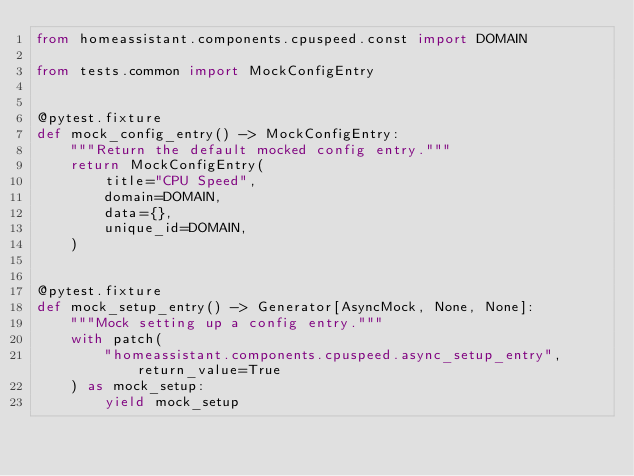Convert code to text. <code><loc_0><loc_0><loc_500><loc_500><_Python_>from homeassistant.components.cpuspeed.const import DOMAIN

from tests.common import MockConfigEntry


@pytest.fixture
def mock_config_entry() -> MockConfigEntry:
    """Return the default mocked config entry."""
    return MockConfigEntry(
        title="CPU Speed",
        domain=DOMAIN,
        data={},
        unique_id=DOMAIN,
    )


@pytest.fixture
def mock_setup_entry() -> Generator[AsyncMock, None, None]:
    """Mock setting up a config entry."""
    with patch(
        "homeassistant.components.cpuspeed.async_setup_entry", return_value=True
    ) as mock_setup:
        yield mock_setup
</code> 